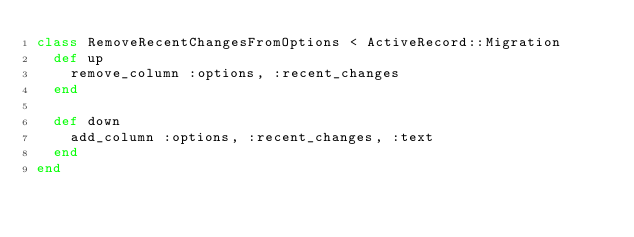<code> <loc_0><loc_0><loc_500><loc_500><_Ruby_>class RemoveRecentChangesFromOptions < ActiveRecord::Migration
  def up
    remove_column :options, :recent_changes
  end

  def down
    add_column :options, :recent_changes, :text
  end
end
</code> 